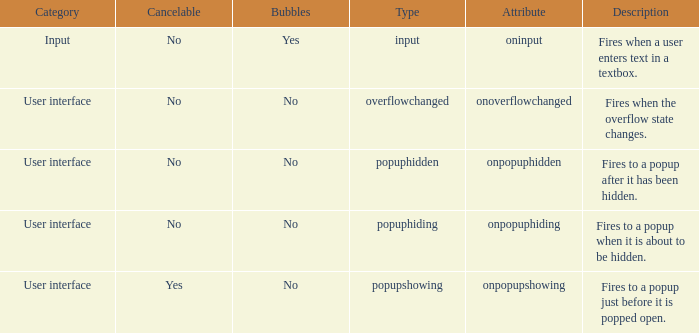What's the cancelable with bubbles being yes No. 